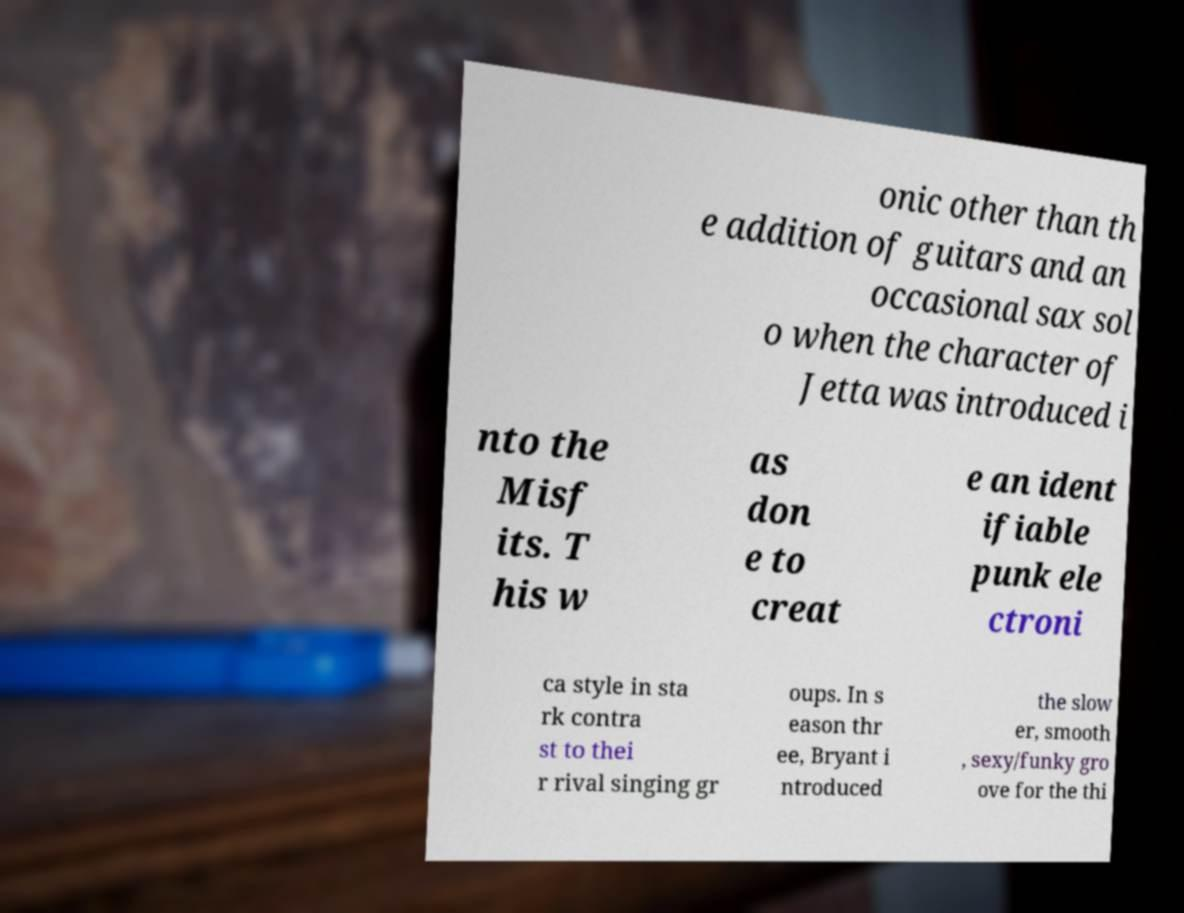Can you accurately transcribe the text from the provided image for me? onic other than th e addition of guitars and an occasional sax sol o when the character of Jetta was introduced i nto the Misf its. T his w as don e to creat e an ident ifiable punk ele ctroni ca style in sta rk contra st to thei r rival singing gr oups. In s eason thr ee, Bryant i ntroduced the slow er, smooth , sexy/funky gro ove for the thi 